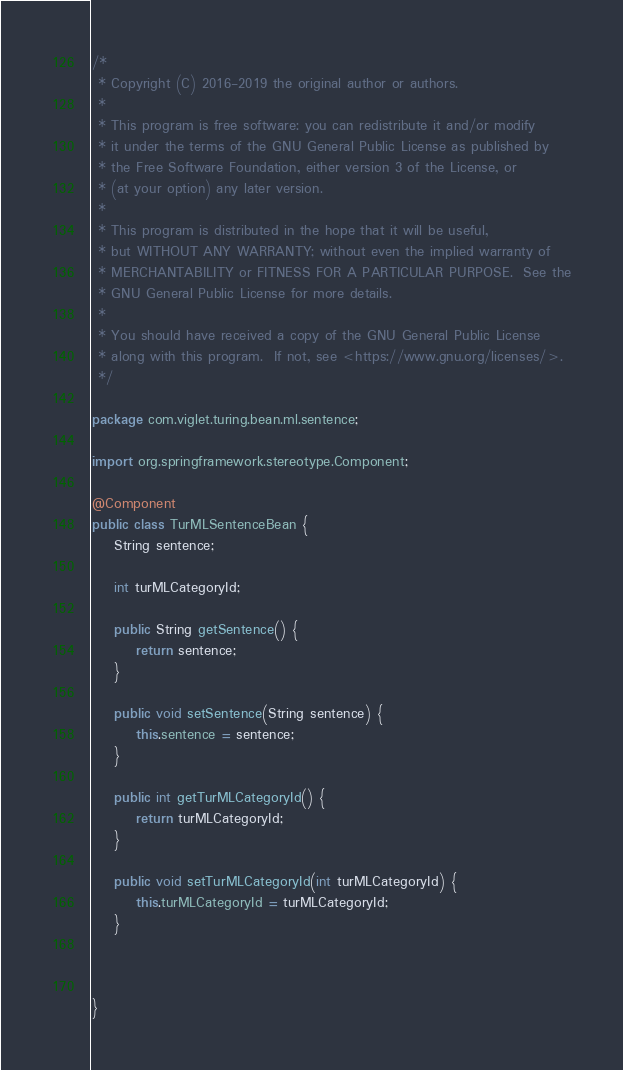Convert code to text. <code><loc_0><loc_0><loc_500><loc_500><_Java_>/*
 * Copyright (C) 2016-2019 the original author or authors. 
 * 
 * This program is free software: you can redistribute it and/or modify
 * it under the terms of the GNU General Public License as published by
 * the Free Software Foundation, either version 3 of the License, or
 * (at your option) any later version.
 *
 * This program is distributed in the hope that it will be useful,
 * but WITHOUT ANY WARRANTY; without even the implied warranty of
 * MERCHANTABILITY or FITNESS FOR A PARTICULAR PURPOSE.  See the
 * GNU General Public License for more details.
 *
 * You should have received a copy of the GNU General Public License
 * along with this program.  If not, see <https://www.gnu.org/licenses/>.
 */

package com.viglet.turing.bean.ml.sentence;

import org.springframework.stereotype.Component;

@Component
public class TurMLSentenceBean {
	String sentence;
	
	int turMLCategoryId;
	
	public String getSentence() {
		return sentence;
	}

	public void setSentence(String sentence) {
		this.sentence = sentence;
	}

	public int getTurMLCategoryId() {
		return turMLCategoryId;
	}

	public void setTurMLCategoryId(int turMLCategoryId) {
		this.turMLCategoryId = turMLCategoryId;
	}



}
</code> 